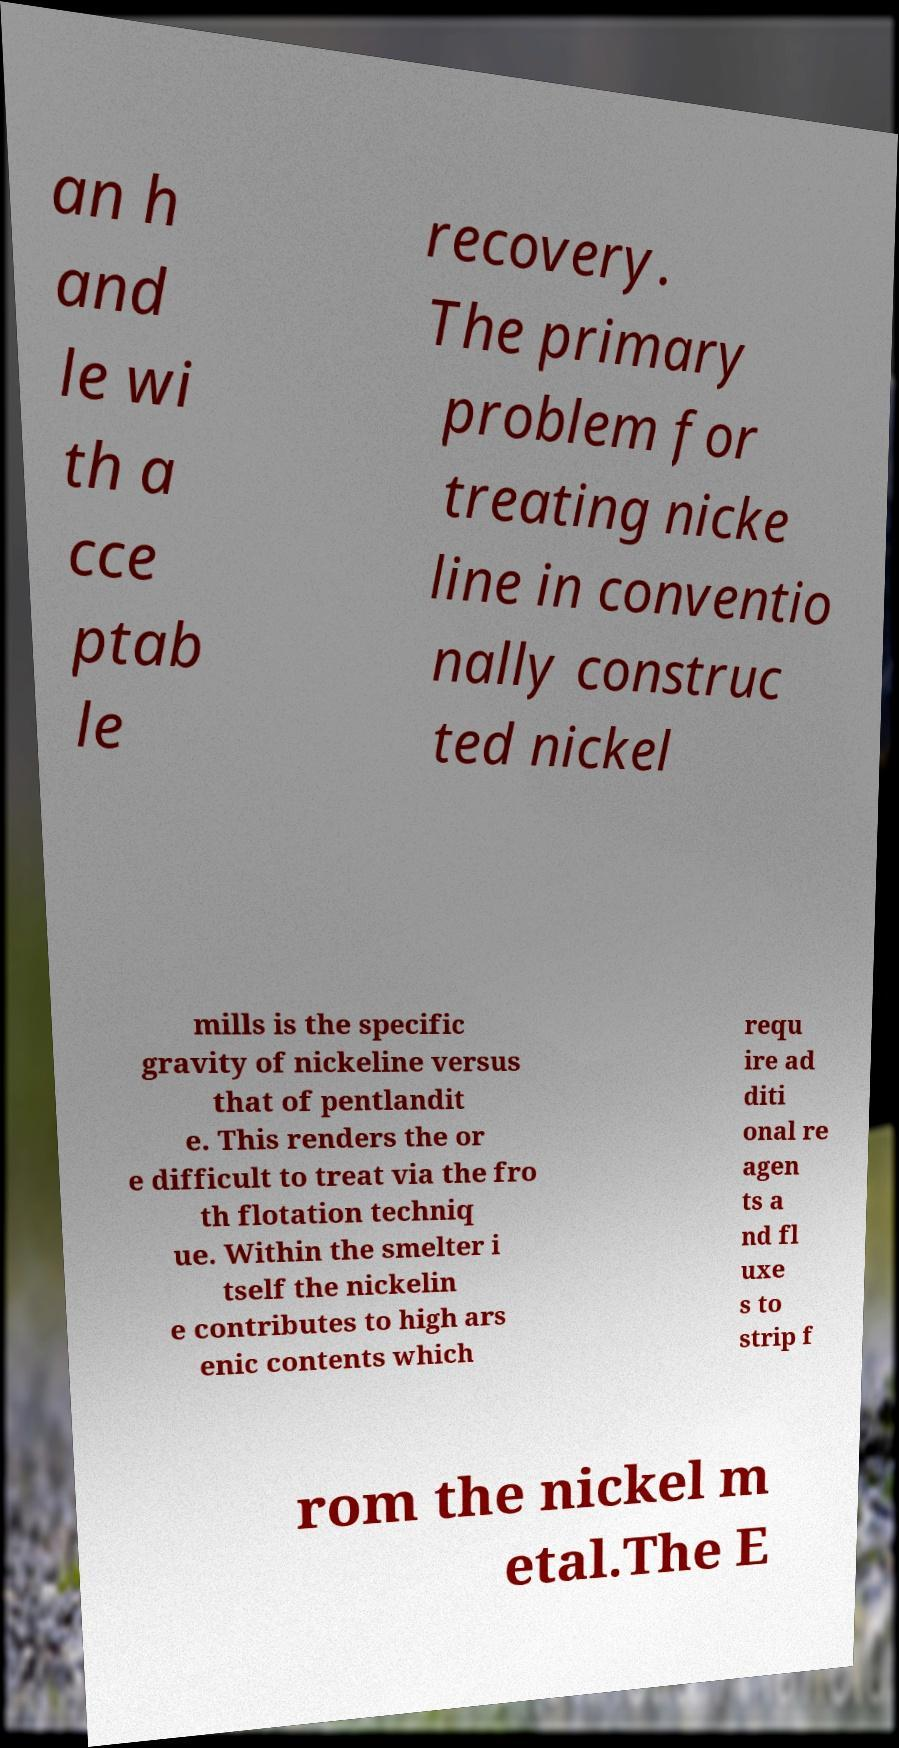Please read and relay the text visible in this image. What does it say? an h and le wi th a cce ptab le recovery. The primary problem for treating nicke line in conventio nally construc ted nickel mills is the specific gravity of nickeline versus that of pentlandit e. This renders the or e difficult to treat via the fro th flotation techniq ue. Within the smelter i tself the nickelin e contributes to high ars enic contents which requ ire ad diti onal re agen ts a nd fl uxe s to strip f rom the nickel m etal.The E 